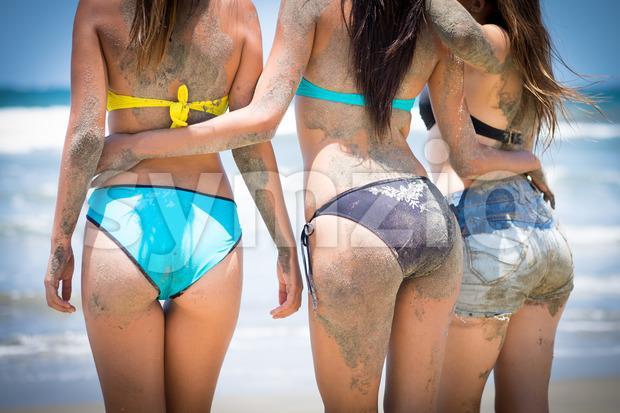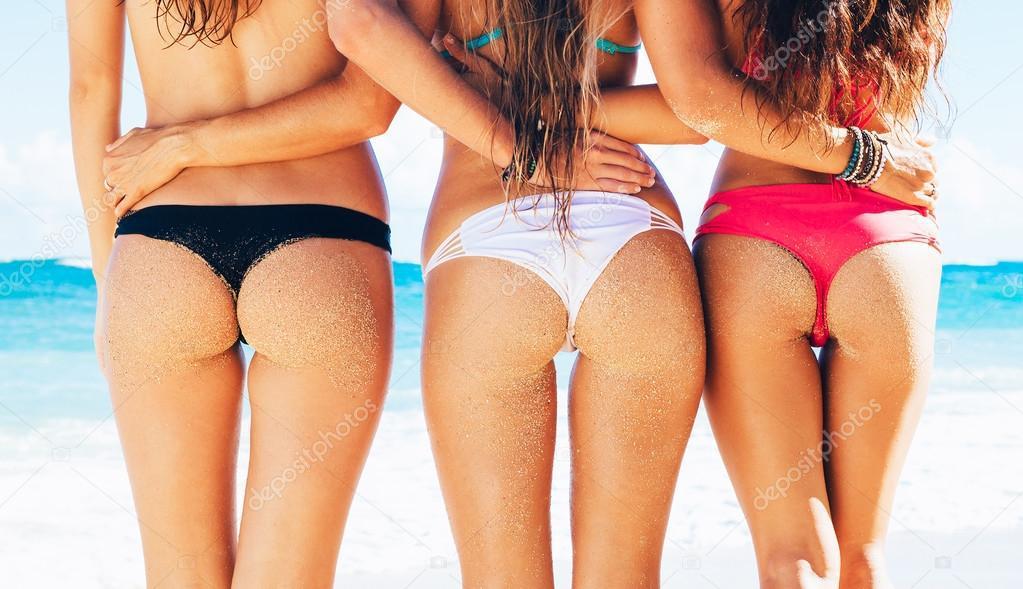The first image is the image on the left, the second image is the image on the right. Analyze the images presented: Is the assertion "Three women are wearing bikinis in each of the images." valid? Answer yes or no. Yes. The first image is the image on the left, the second image is the image on the right. Analyze the images presented: Is the assertion "At least one image depicts a trio of rear-facing arm-linked models in front of water." valid? Answer yes or no. Yes. 